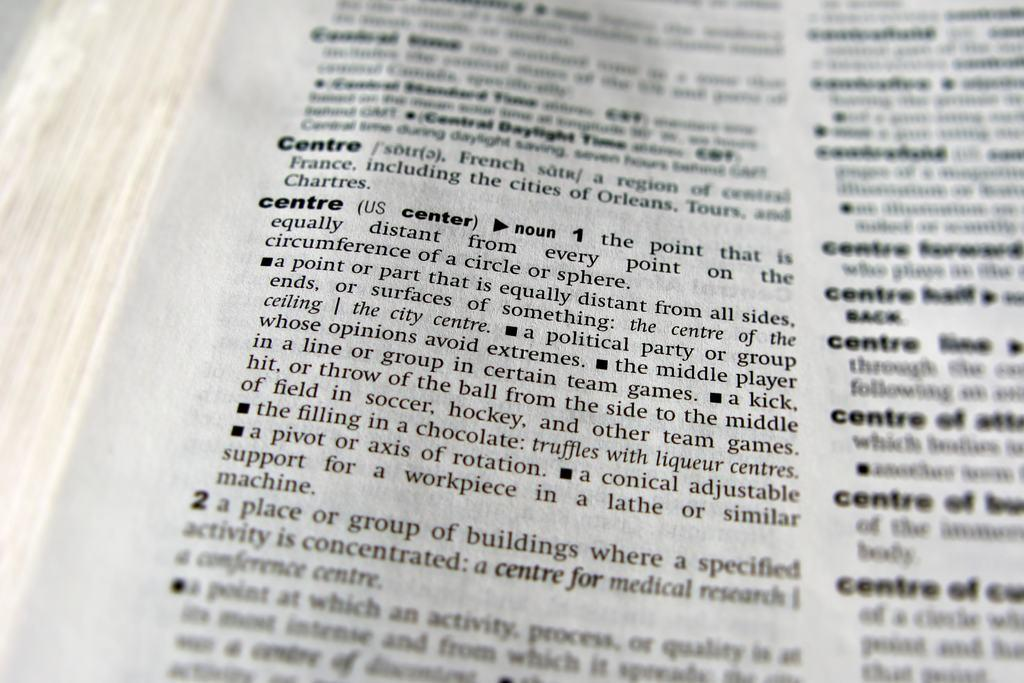<image>
Relay a brief, clear account of the picture shown. A close up view of a dictionary page with the definition of the word "centre" showing. 